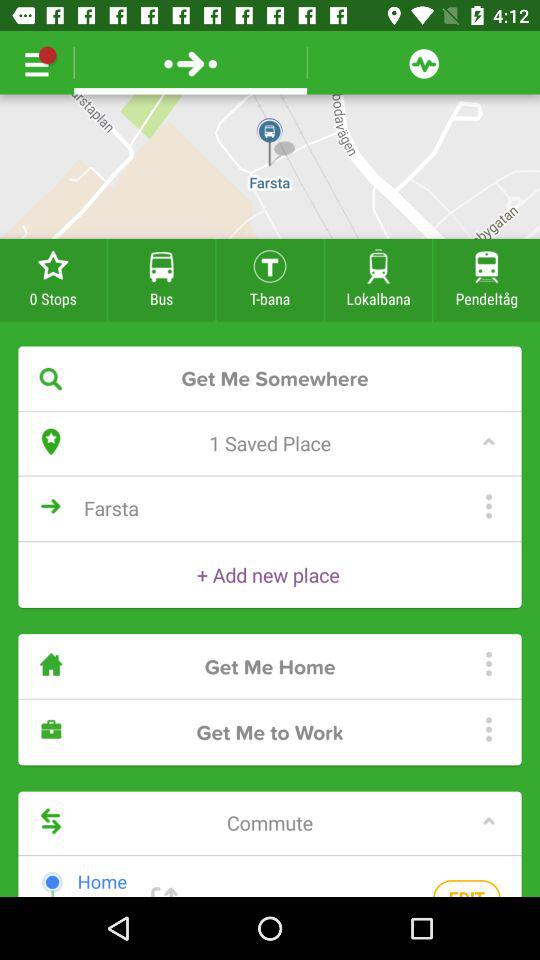How many saved places are there?
Answer the question using a single word or phrase. 1 